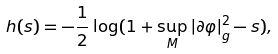<formula> <loc_0><loc_0><loc_500><loc_500>h ( s ) = - \frac { 1 } { 2 } \log ( 1 + \sup _ { M } | \partial \varphi | ^ { 2 } _ { g } - s ) ,</formula> 